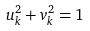Convert formula to latex. <formula><loc_0><loc_0><loc_500><loc_500>u _ { k } ^ { 2 } + v _ { k } ^ { 2 } = 1</formula> 